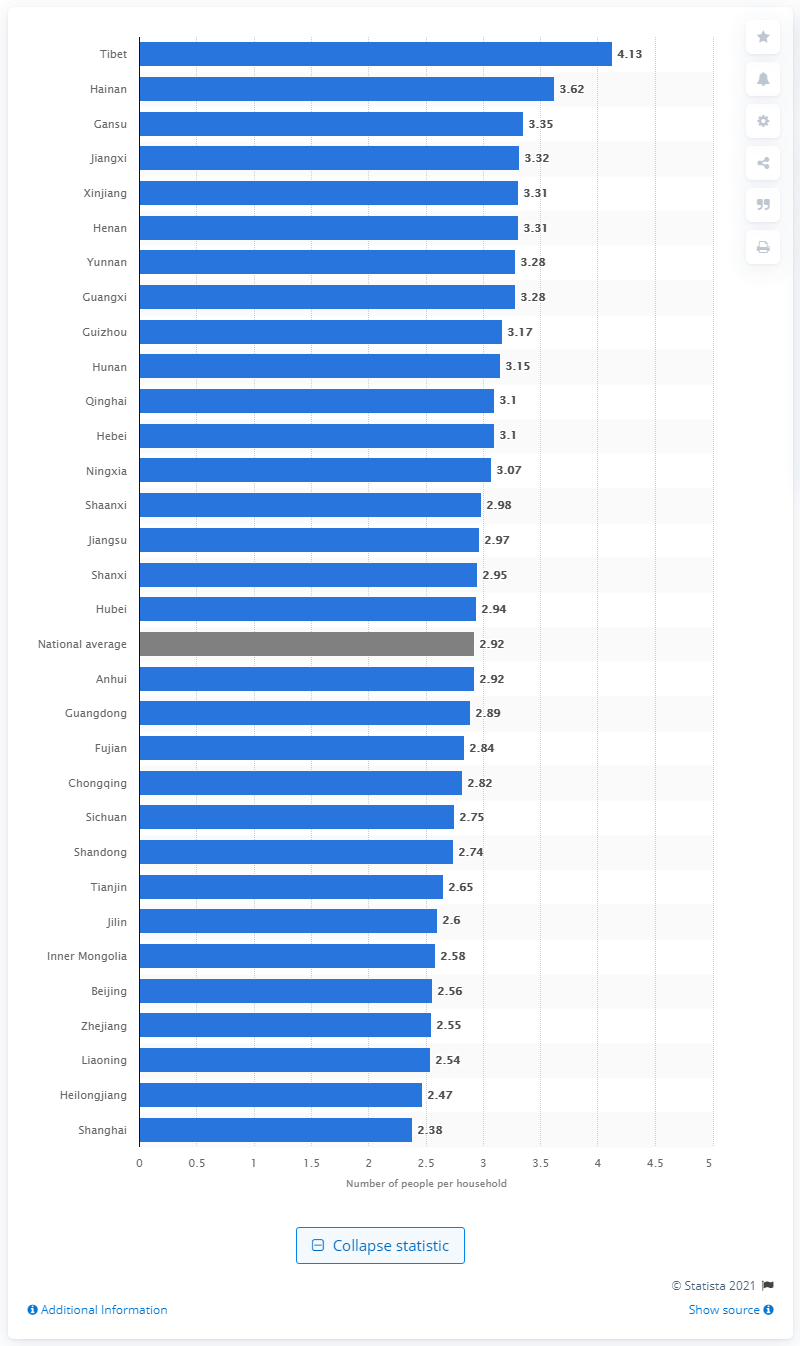List a handful of essential elements in this visual. In 2019, the average number of people per household in Tibet was 4.13. In 2019, the national average number of people per household in China was 2.92. In 2019, the average number of people per household in Shanghai was 2.38. 